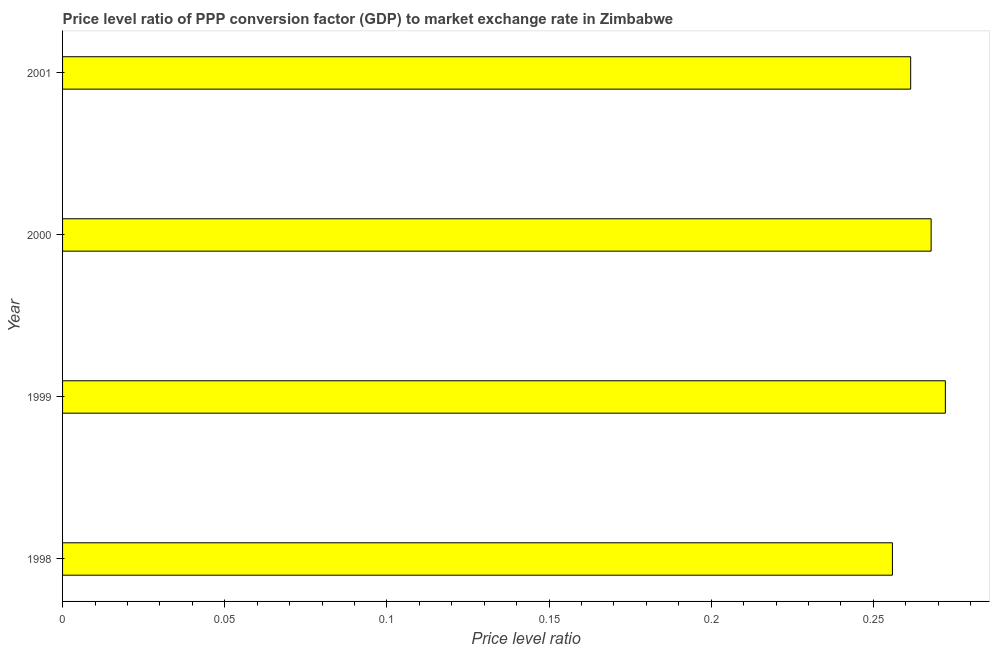Does the graph contain any zero values?
Ensure brevity in your answer.  No. What is the title of the graph?
Your answer should be very brief. Price level ratio of PPP conversion factor (GDP) to market exchange rate in Zimbabwe. What is the label or title of the X-axis?
Keep it short and to the point. Price level ratio. What is the price level ratio in 2000?
Your response must be concise. 0.27. Across all years, what is the maximum price level ratio?
Your response must be concise. 0.27. Across all years, what is the minimum price level ratio?
Your response must be concise. 0.26. What is the sum of the price level ratio?
Provide a short and direct response. 1.06. What is the difference between the price level ratio in 1998 and 2000?
Provide a succinct answer. -0.01. What is the average price level ratio per year?
Give a very brief answer. 0.26. What is the median price level ratio?
Your response must be concise. 0.26. What is the difference between the highest and the second highest price level ratio?
Provide a short and direct response. 0. Is the sum of the price level ratio in 1999 and 2000 greater than the maximum price level ratio across all years?
Provide a succinct answer. Yes. What is the difference between the highest and the lowest price level ratio?
Your answer should be very brief. 0.02. How many bars are there?
Keep it short and to the point. 4. Are all the bars in the graph horizontal?
Your response must be concise. Yes. What is the Price level ratio of 1998?
Provide a succinct answer. 0.26. What is the Price level ratio of 1999?
Provide a succinct answer. 0.27. What is the Price level ratio in 2000?
Ensure brevity in your answer.  0.27. What is the Price level ratio of 2001?
Ensure brevity in your answer.  0.26. What is the difference between the Price level ratio in 1998 and 1999?
Make the answer very short. -0.02. What is the difference between the Price level ratio in 1998 and 2000?
Keep it short and to the point. -0.01. What is the difference between the Price level ratio in 1998 and 2001?
Ensure brevity in your answer.  -0.01. What is the difference between the Price level ratio in 1999 and 2000?
Keep it short and to the point. 0. What is the difference between the Price level ratio in 1999 and 2001?
Your answer should be compact. 0.01. What is the difference between the Price level ratio in 2000 and 2001?
Give a very brief answer. 0.01. What is the ratio of the Price level ratio in 1998 to that in 2000?
Offer a terse response. 0.95. What is the ratio of the Price level ratio in 1999 to that in 2000?
Offer a very short reply. 1.02. What is the ratio of the Price level ratio in 1999 to that in 2001?
Provide a short and direct response. 1.04. What is the ratio of the Price level ratio in 2000 to that in 2001?
Give a very brief answer. 1.02. 